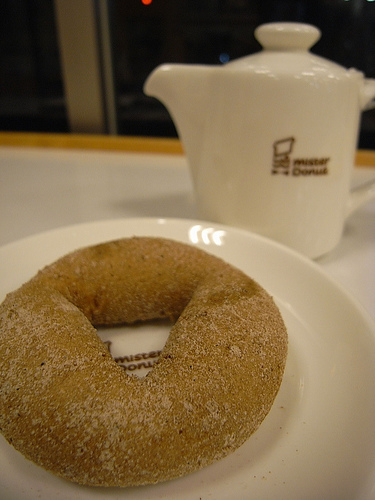Extract all visible text content from this image. misteR 